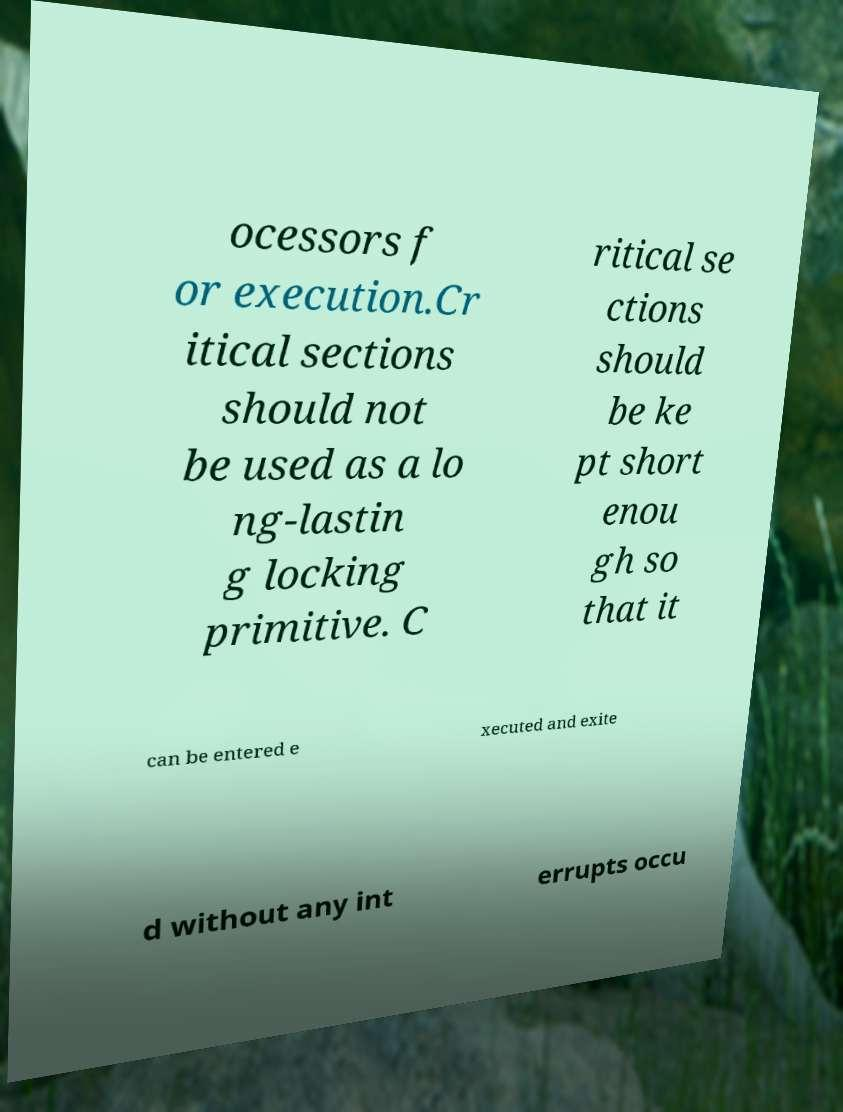What messages or text are displayed in this image? I need them in a readable, typed format. ocessors f or execution.Cr itical sections should not be used as a lo ng-lastin g locking primitive. C ritical se ctions should be ke pt short enou gh so that it can be entered e xecuted and exite d without any int errupts occu 